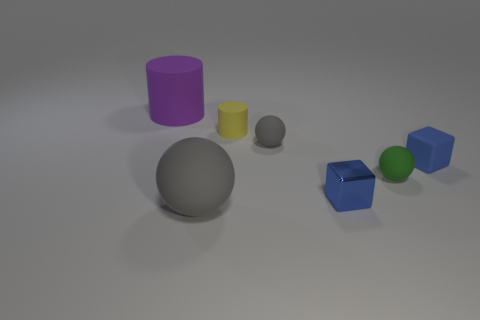Is the small shiny thing the same color as the tiny matte cube?
Offer a terse response. Yes. There is a thing that is the same color as the matte block; what is its material?
Your answer should be compact. Metal. What material is the small green thing that is the same shape as the big gray matte thing?
Provide a succinct answer. Rubber. What material is the big purple object?
Ensure brevity in your answer.  Rubber. Is there a blue ball?
Provide a short and direct response. No. Are there an equal number of shiny objects behind the tiny gray matte sphere and large gray rubber spheres?
Offer a terse response. No. Is there any other thing that is made of the same material as the large cylinder?
Provide a short and direct response. Yes. How many tiny objects are either green matte objects or brown rubber cubes?
Offer a terse response. 1. There is a small matte thing that is the same color as the tiny metallic block; what shape is it?
Your answer should be very brief. Cube. Do the thing to the right of the small green rubber object and the large purple thing have the same material?
Your answer should be very brief. Yes. 